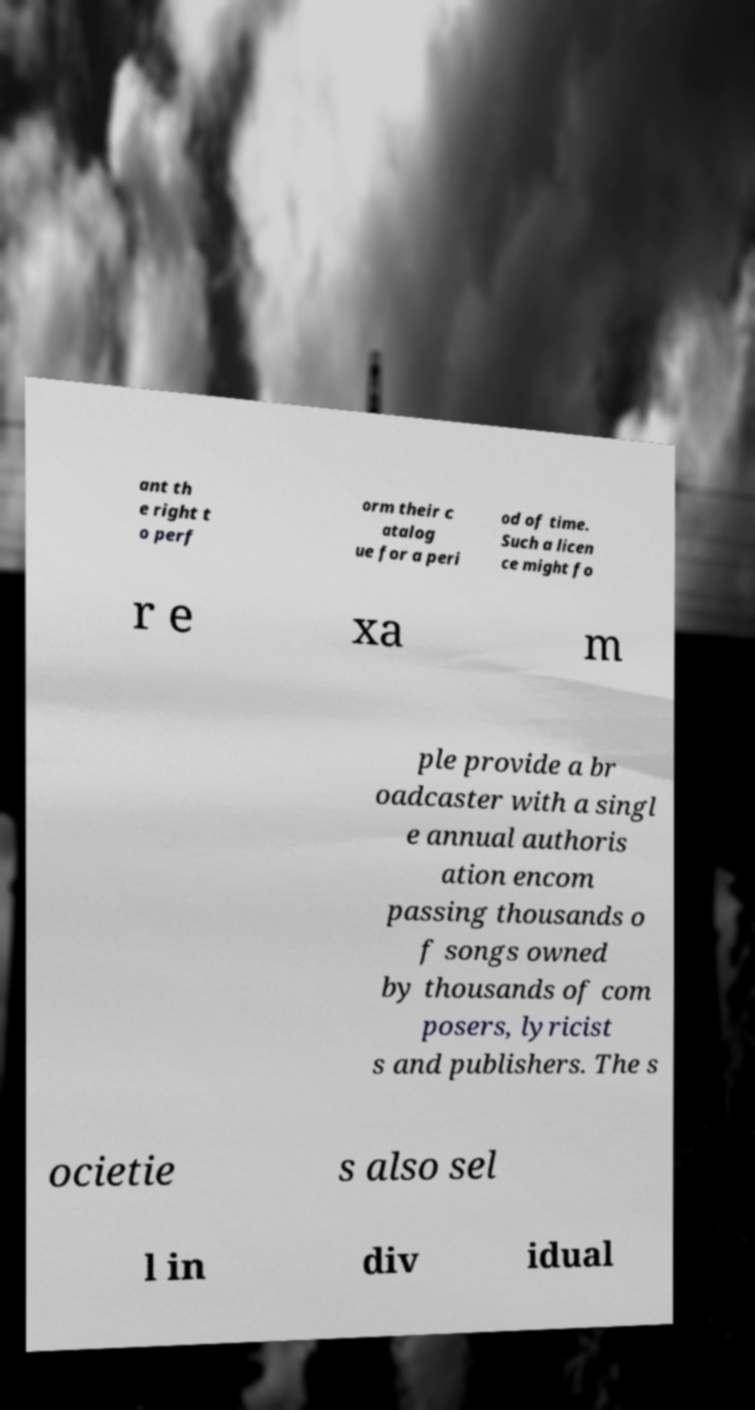There's text embedded in this image that I need extracted. Can you transcribe it verbatim? ant th e right t o perf orm their c atalog ue for a peri od of time. Such a licen ce might fo r e xa m ple provide a br oadcaster with a singl e annual authoris ation encom passing thousands o f songs owned by thousands of com posers, lyricist s and publishers. The s ocietie s also sel l in div idual 